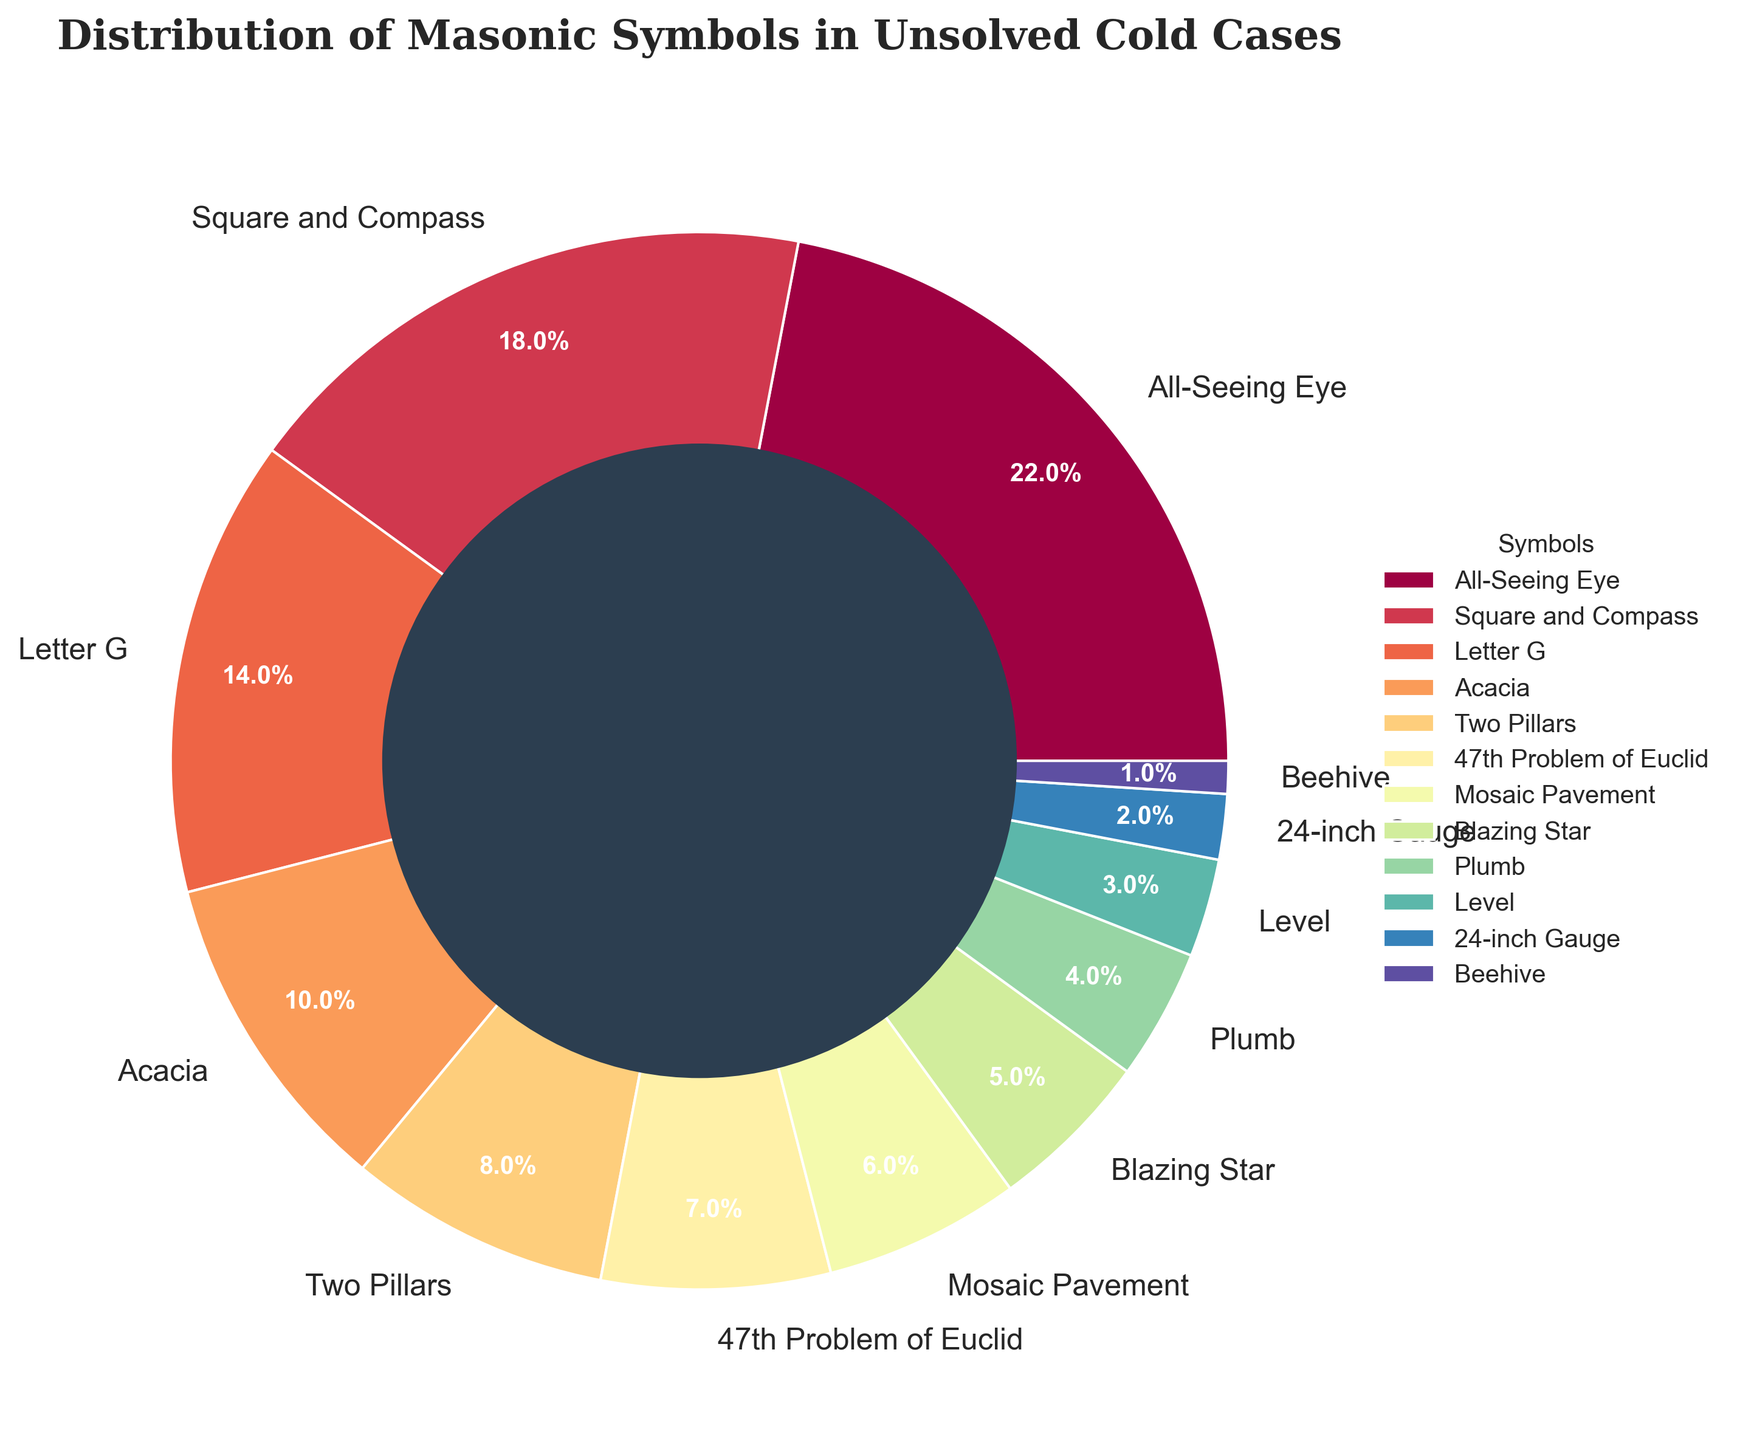Which symbol has the highest percentage? The symbol with the highest percentage can be identified by finding the largest segment in the pie chart. The "All-Seeing Eye" has the largest segment, indicating it has the highest percentage at 22%.
Answer: All-Seeing Eye What is the combined percentage of "Square and Compass" and "Letter G"? To find the combined percentage of "Square and Compass" and "Letter G", add their individual percentages: 18% + 14% = 32%.
Answer: 32% Is the percentage of "Acacia" greater than "47th Problem of Euclid"? By comparing the segments representing "Acacia" and "47th Problem of Euclid", we see that "Acacia" has a percentage of 10% while "47th Problem of Euclid" has 7%. Therefore, "Acacia" is greater.
Answer: Yes What is the total percentage of symbols that have a percentage lower than 5%? Adding the percentages of symbols with values lower than 5%, i.e., "Plumb" (4%), "Level" (3%), "24-inch Gauge" (2%), and "Beehive" (1%): 4% + 3% + 2% + 1% = 10%.
Answer: 10% How much higher is the percentage of "Blazing Star" compared to "Beehive"? To determine how much higher "Blazing Star" is compared to "Beehive", subtract the percentage of "Beehive" from that of "Blazing Star": 5% - 1% = 4%.
Answer: 4% Which symbols have a percentage value between 5% and 10%? Symbols that fall within the 5% to 10% range can be identified as "Mosaic Pavement" (6%) and "Two Pillars" (8%).
Answer: Mosaic Pavement, Two Pillars What is the sum of percentages for symbols that have 'e' in their name? Symbols with 'e' in their names are "All-Seeing Eye" (22%), "Square and Compass" (18%), "Letter G" (14%), "47th Problem of Euclid" (7%), and "Beehive" (1%). Sum: 22% + 18% + 14% + 7% + 1% = 62%.
Answer: 62% Which symbols have a percentage greater than "47th Problem of Euclid" but less than "Square and Compass"? By comparing percentages, the symbols meeting the criteria are "Two Pillars" (8%), "Acacia" (10%), and "Letter G" (14%).
Answer: Two Pillars, Acacia, Letter G What is the average percentage of the top three symbols? The percentages of the top three symbols are "All-Seeing Eye" (22%), "Square and Compass" (18%), and "Letter G" (14%). Calculate the average: (22% + 18% + 14%) / 3 = 54% / 3 = 18%.
Answer: 18% Is the percentage of "Blazing Star" less than the combined percentage of "Plumb" and "24-inch Gauge"? Adding the percentages of "Plumb" (4%) and "24-inch Gauge" (2%) gives 6%. The "Blazing Star" has 5%, which is less than 6%.
Answer: Yes 